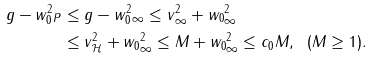Convert formula to latex. <formula><loc_0><loc_0><loc_500><loc_500>\| g - w _ { 0 } ^ { 2 } \| _ { P } & \leq \| g - w _ { 0 } ^ { 2 } \| _ { \infty } \leq \| v \| _ { \infty } ^ { 2 } + \| w _ { 0 } \| _ { \infty } ^ { 2 } \\ & \leq \| v \| _ { \mathcal { H } } ^ { 2 } + \| w _ { 0 } \| _ { \infty } ^ { 2 } \leq M + \| w _ { 0 } \| _ { \infty } ^ { 2 } \leq c _ { 0 } M , \ \ ( M \geq 1 ) .</formula> 